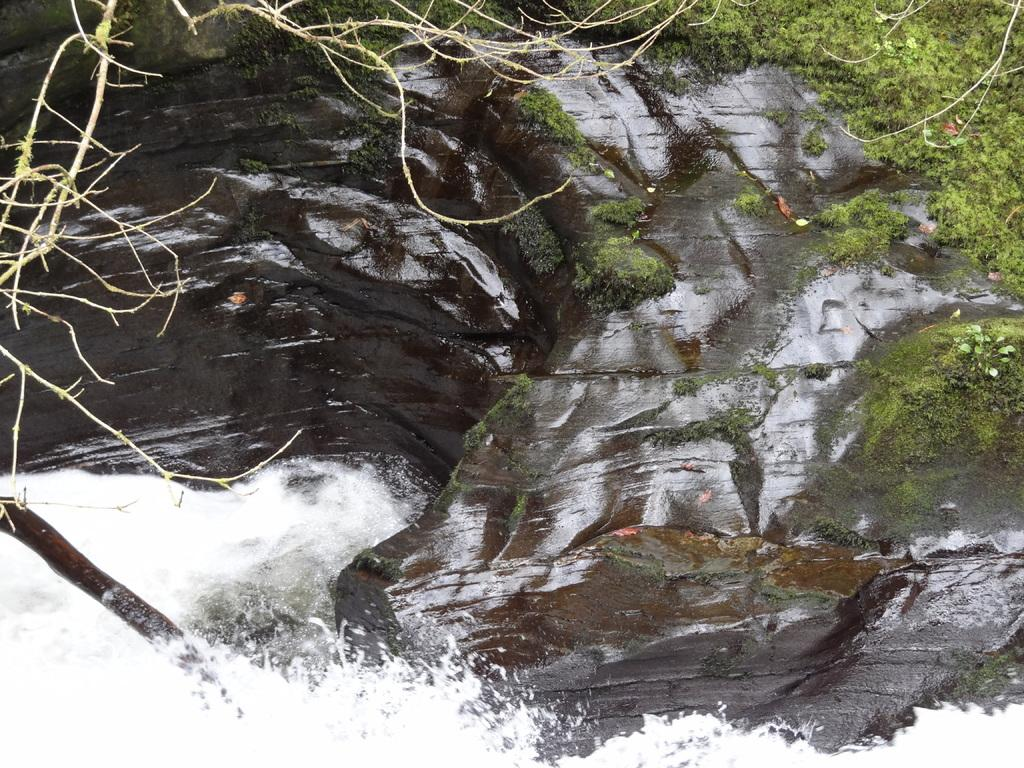What is happening on the rock in the image? Water is flowing on the rock, and there is grass on the rock. What else can be seen in the image besides the rock and water? Branches are visible in the image. What type of humor can be seen in the image? There is no humor present in the image; it features water flowing on a rock with grass and branches. Is there a button visible in the image? There is no button present in the image. 